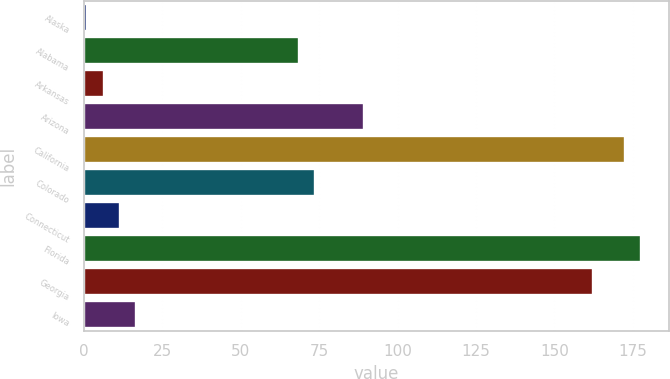Convert chart to OTSL. <chart><loc_0><loc_0><loc_500><loc_500><bar_chart><fcel>Alaska<fcel>Alabama<fcel>Arkansas<fcel>Arizona<fcel>California<fcel>Colorado<fcel>Connecticut<fcel>Florida<fcel>Georgia<fcel>Iowa<nl><fcel>1<fcel>68.6<fcel>6.2<fcel>89.4<fcel>172.6<fcel>73.8<fcel>11.4<fcel>177.8<fcel>162.2<fcel>16.6<nl></chart> 